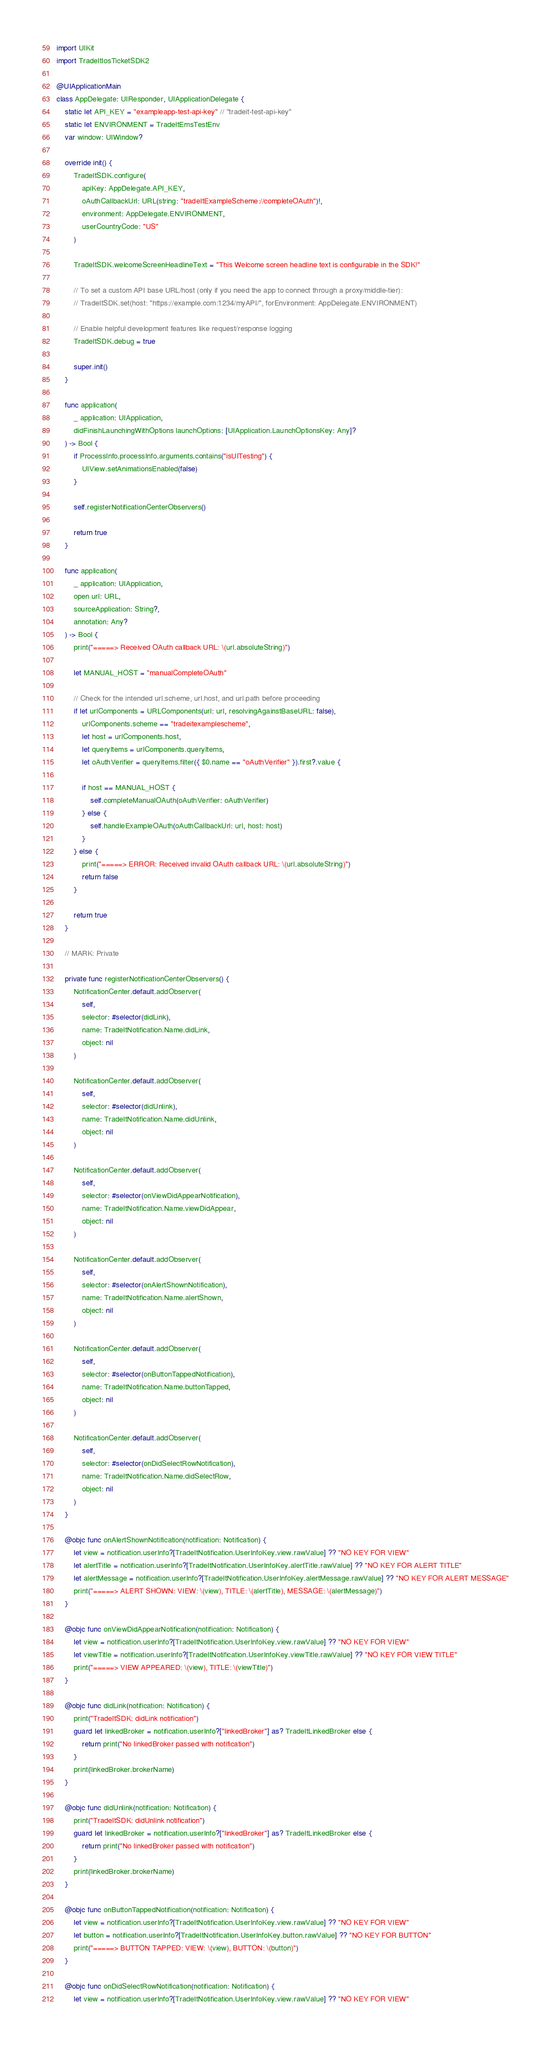Convert code to text. <code><loc_0><loc_0><loc_500><loc_500><_Swift_>import UIKit
import TradeItIosTicketSDK2

@UIApplicationMain
class AppDelegate: UIResponder, UIApplicationDelegate {
    static let API_KEY = "exampleapp-test-api-key" // "tradeit-test-api-key"
    static let ENVIRONMENT = TradeItEmsTestEnv
    var window: UIWindow?

    override init() {
        TradeItSDK.configure(
            apiKey: AppDelegate.API_KEY,
            oAuthCallbackUrl: URL(string: "tradeItExampleScheme://completeOAuth")!,
            environment: AppDelegate.ENVIRONMENT,
            userCountryCode: "US"
        )
        
        TradeItSDK.welcomeScreenHeadlineText = "This Welcome screen headline text is configurable in the SDK!"

        // To set a custom API base URL/host (only if you need the app to connect through a proxy/middle-tier):
        // TradeItSDK.set(host: "https://example.com:1234/myAPI/", forEnvironment: AppDelegate.ENVIRONMENT)

        // Enable helpful development features like request/response logging
        TradeItSDK.debug = true

        super.init()
    }

    func application(
        _ application: UIApplication,
        didFinishLaunchingWithOptions launchOptions: [UIApplication.LaunchOptionsKey: Any]?
    ) -> Bool {
        if ProcessInfo.processInfo.arguments.contains("isUITesting") {
            UIView.setAnimationsEnabled(false)
        }

        self.registerNotificationCenterObservers()

        return true
    }

    func application(
        _ application: UIApplication,
        open url: URL,
        sourceApplication: String?,
        annotation: Any?
    ) -> Bool {
        print("=====> Received OAuth callback URL: \(url.absoluteString)")

        let MANUAL_HOST = "manualCompleteOAuth"

        // Check for the intended url.scheme, url.host, and url.path before proceeding
        if let urlComponents = URLComponents(url: url, resolvingAgainstBaseURL: false),
            urlComponents.scheme == "tradeitexamplescheme",
            let host = urlComponents.host,
            let queryItems = urlComponents.queryItems,
            let oAuthVerifier = queryItems.filter({ $0.name == "oAuthVerifier" }).first?.value {

            if host == MANUAL_HOST {
                self.completeManualOAuth(oAuthVerifier: oAuthVerifier)
            } else {
                self.handleExampleOAuth(oAuthCallbackUrl: url, host: host)
            }
        } else {
            print("=====> ERROR: Received invalid OAuth callback URL: \(url.absoluteString)")
            return false
        }

        return true
    }

    // MARK: Private

    private func registerNotificationCenterObservers() {
        NotificationCenter.default.addObserver(
            self,
            selector: #selector(didLink),
            name: TradeItNotification.Name.didLink,
            object: nil
        )

        NotificationCenter.default.addObserver(
            self,
            selector: #selector(didUnlink),
            name: TradeItNotification.Name.didUnlink,
            object: nil
        )

        NotificationCenter.default.addObserver(
            self,
            selector: #selector(onViewDidAppearNotification),
            name: TradeItNotification.Name.viewDidAppear,
            object: nil
        )

        NotificationCenter.default.addObserver(
            self,
            selector: #selector(onAlertShownNotification),
            name: TradeItNotification.Name.alertShown,
            object: nil
        )

        NotificationCenter.default.addObserver(
            self,
            selector: #selector(onButtonTappedNotification),
            name: TradeItNotification.Name.buttonTapped,
            object: nil
        )

        NotificationCenter.default.addObserver(
            self,
            selector: #selector(onDidSelectRowNotification),
            name: TradeItNotification.Name.didSelectRow,
            object: nil
        )
    }

    @objc func onAlertShownNotification(notification: Notification) {
        let view = notification.userInfo?[TradeItNotification.UserInfoKey.view.rawValue] ?? "NO KEY FOR VIEW"
        let alertTitle = notification.userInfo?[TradeItNotification.UserInfoKey.alertTitle.rawValue] ?? "NO KEY FOR ALERT TITLE"
        let alertMessage = notification.userInfo?[TradeItNotification.UserInfoKey.alertMessage.rawValue] ?? "NO KEY FOR ALERT MESSAGE"
        print("=====> ALERT SHOWN: VIEW: \(view), TITLE: \(alertTitle), MESSAGE: \(alertMessage)")
    }

    @objc func onViewDidAppearNotification(notification: Notification) {
        let view = notification.userInfo?[TradeItNotification.UserInfoKey.view.rawValue] ?? "NO KEY FOR VIEW"
        let viewTitle = notification.userInfo?[TradeItNotification.UserInfoKey.viewTitle.rawValue] ?? "NO KEY FOR VIEW TITLE"
        print("=====> VIEW APPEARED: \(view), TITLE: \(viewTitle)")
    }

    @objc func didLink(notification: Notification) {
        print("TradeItSDK: didLink notification")
        guard let linkedBroker = notification.userInfo?["linkedBroker"] as? TradeItLinkedBroker else {
            return print("No linkedBroker passed with notification")
        }
        print(linkedBroker.brokerName)
    }

    @objc func didUnlink(notification: Notification) {
        print("TradeItSDK: didUnlink notification")
        guard let linkedBroker = notification.userInfo?["linkedBroker"] as? TradeItLinkedBroker else {
            return print("No linkedBroker passed with notification")
        }
        print(linkedBroker.brokerName)
    }

    @objc func onButtonTappedNotification(notification: Notification) {
        let view = notification.userInfo?[TradeItNotification.UserInfoKey.view.rawValue] ?? "NO KEY FOR VIEW"
        let button = notification.userInfo?[TradeItNotification.UserInfoKey.button.rawValue] ?? "NO KEY FOR BUTTON"
        print("=====> BUTTON TAPPED: VIEW: \(view), BUTTON: \(button)")
    }

    @objc func onDidSelectRowNotification(notification: Notification) {
        let view = notification.userInfo?[TradeItNotification.UserInfoKey.view.rawValue] ?? "NO KEY FOR VIEW"</code> 